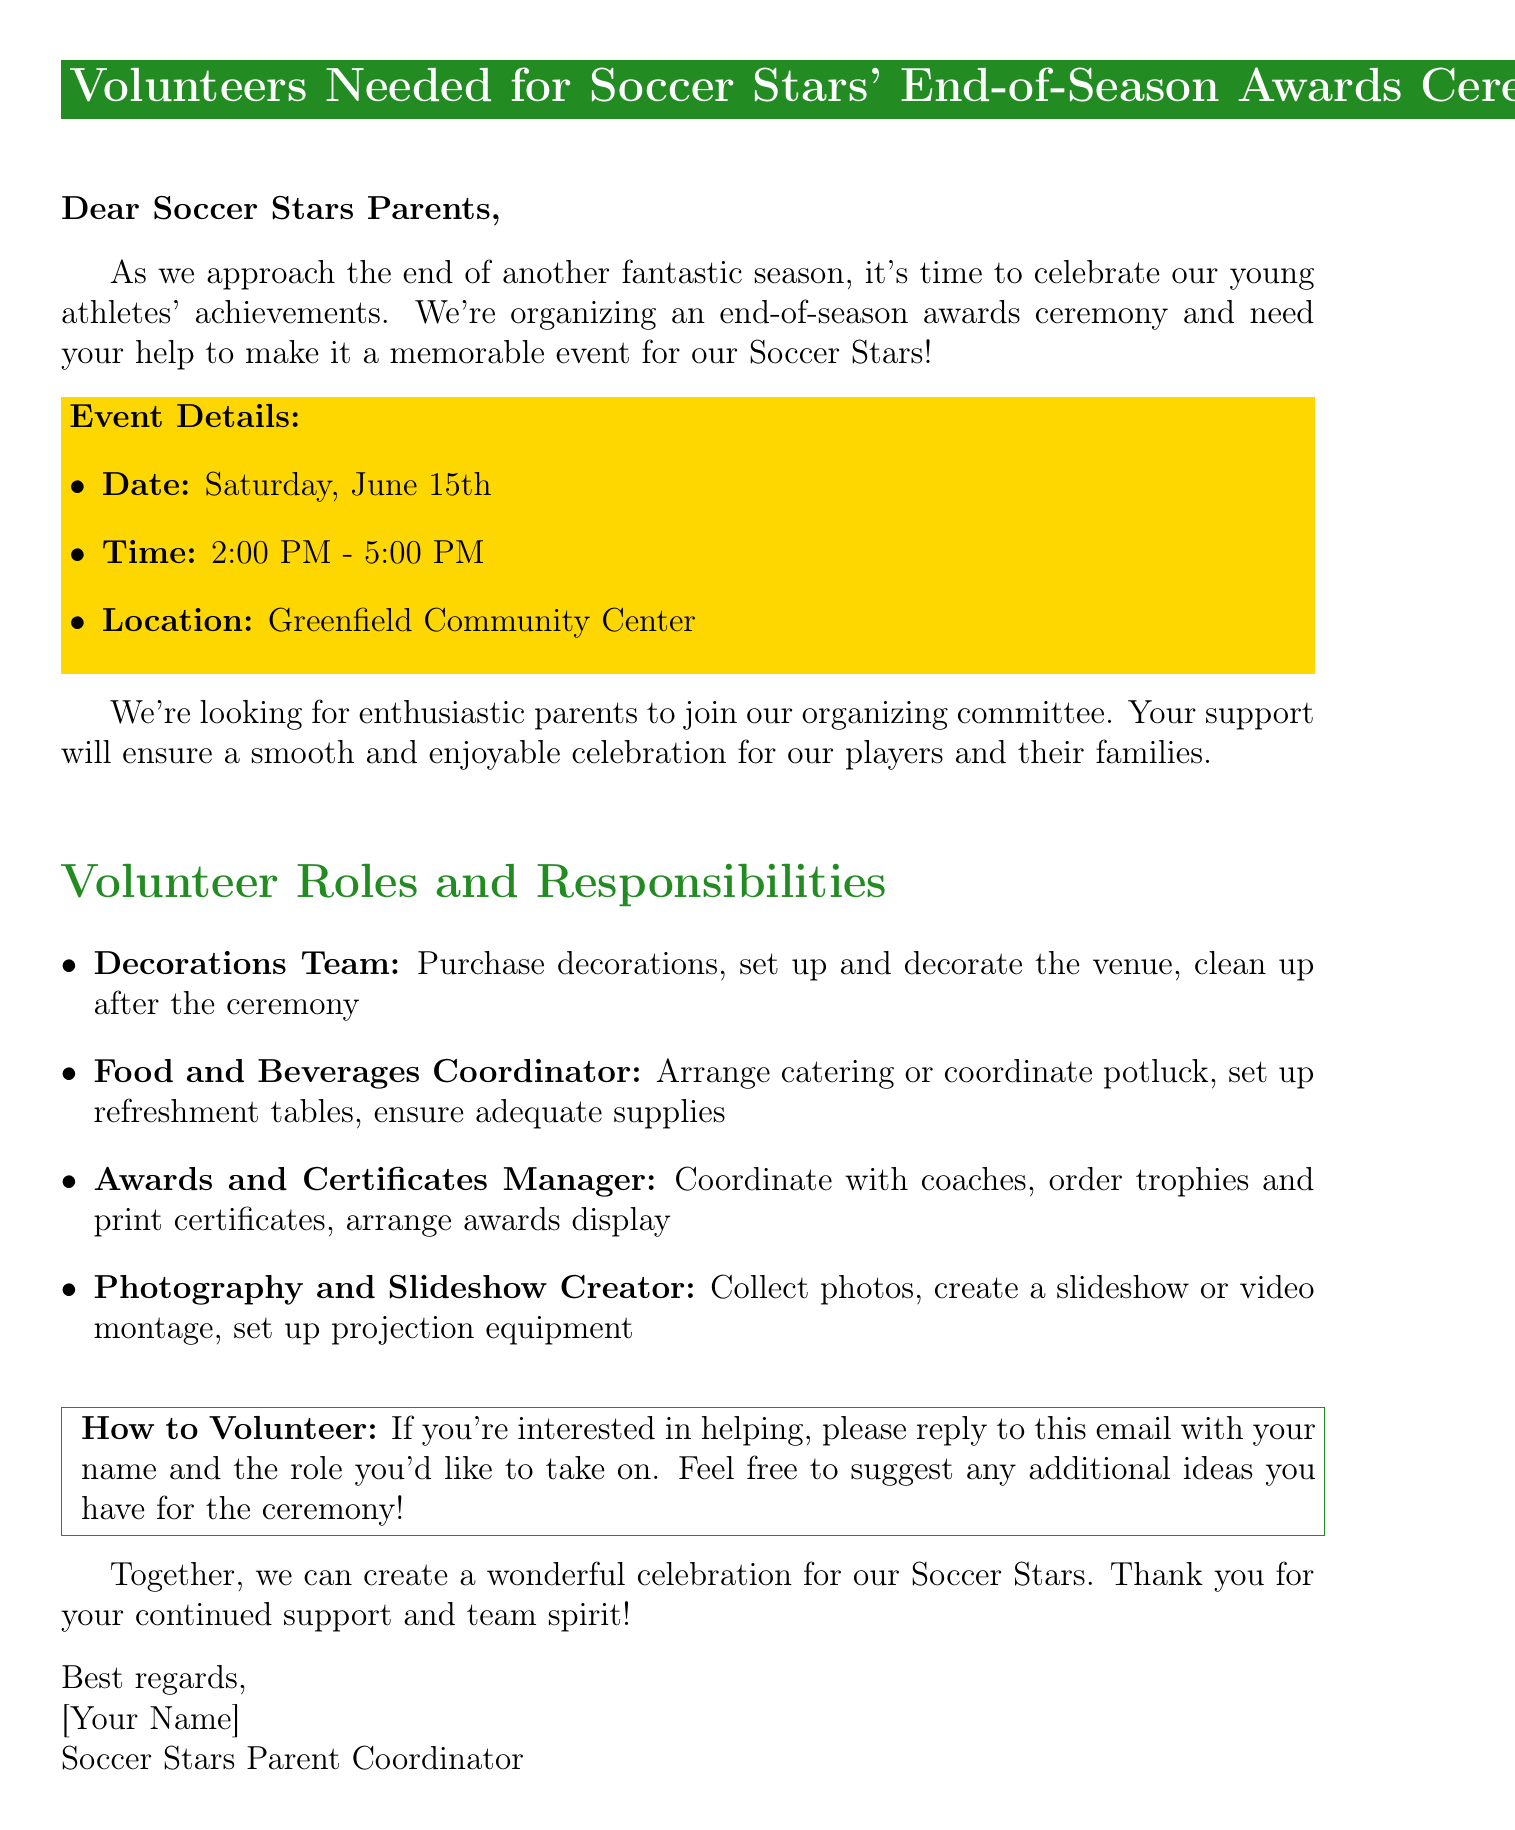What is the date of the event? The date of the event is mentioned in the document as Saturday, June 15th.
Answer: Saturday, June 15th What time does the ceremony start? The start time of the ceremony is explicitly stated in the document as 2:00 PM.
Answer: 2:00 PM What team is being recognized at the ceremony? The ceremony is organized to celebrate the achievements of the Soccer Stars.
Answer: Soccer Stars Who needs to respond to volunteer? The email requests parents to reply if they wish to volunteer.
Answer: Parents What role is responsible for arranging decorations? The document specifies that the Decorations Team is responsible for decorations.
Answer: Decorations Team How long is the event scheduled to last? The time frame provided indicates the ceremony will last for 3 hours, from 2:00 PM to 5:00 PM.
Answer: 3 hours What should be collected for the photography task? The Photography and Slideshow Creator is tasked with collecting photos from the season.
Answer: Photos What should volunteers include in their response? Volunteers are asked to include their name and the role they would like to take on in their response.
Answer: Name and role 